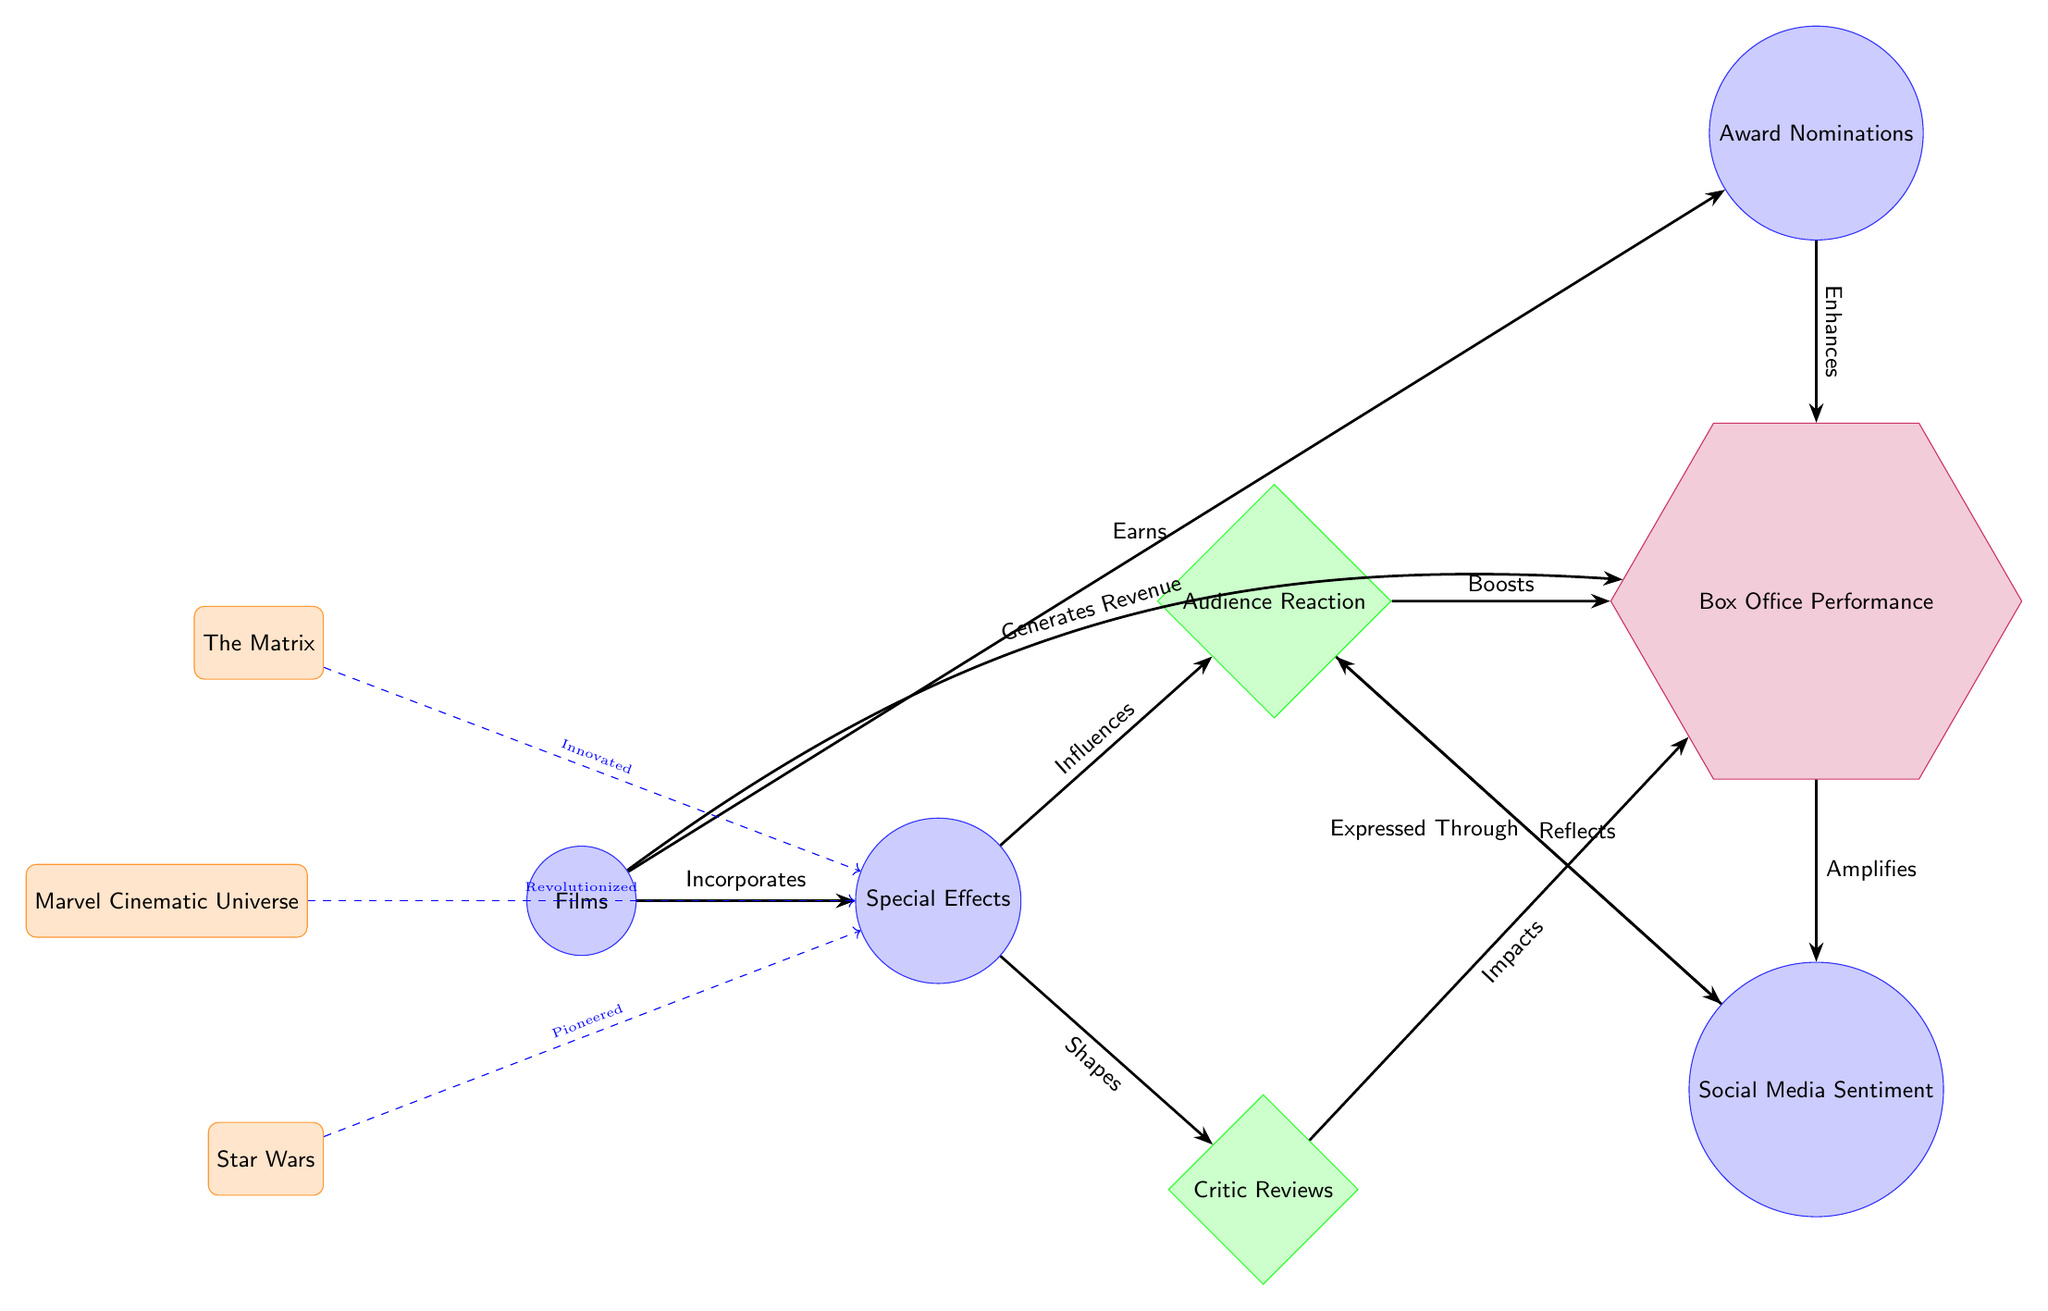What is the primary concept depicted at the leftmost node? The leftmost node represents the primary concept of "Films," indicating that the entire diagram revolves around the influence and relationships originating from films.
Answer: Films How many major reactions are illustrated in the diagram? There are two major reactions depicted: "Audience Reaction" and "Critic Reviews," showcasing the differing impacts that special effects have on audience and critic sentiments.
Answer: 2 Which film is noted for pioneering special effects? The diagram indicates that "Star Wars" is credited with pioneering special effects, pointing to its significant role in the evolution of the industry.
Answer: Star Wars What is the relationship between "Audience Reaction" and "Box Office Performance"? The diagram shows that audience reactions "Boost" box office performance, illustrating the direct influence that audience sentiment has on financial success.
Answer: Boosts How does "Social Media Sentiment" relate to "Audience Reaction"? "Social Media Sentiment" "Reflects" audience reaction, indicating that public responses on social media platforms are indicative of audience reactions to films.
Answer: Reflects Which concept enhances box office performance through award nominations? The concept "Awards" is shown to "Enhance" box office performance, demonstrating that being nominated for awards can positively influence a film’s financial success.
Answer: Enhances What impact do critic reviews have on box office performance? The diagram illustrates that critic reviews "Impacts" box office performance, suggesting that critics' responses to films can influence audience turnout and resulting revenue.
Answer: Impacts Which films are illustrated as having revolutionized special effects? The diagram lists "Marvel Cinematic Universe" as a film that has revolutionized special effects, indicating its significant contributions following the earlier breakthroughs.
Answer: Marvel Cinematic Universe How many arrows point to the "Box Office Performance" node? There are four arrows pointing to "Box Office Performance," indicating various influences from films, audience reactions, critic reviews, and awards nominations.
Answer: 4 